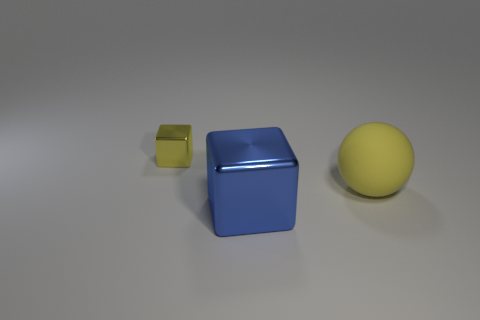Add 3 large things. How many objects exist? 6 Subtract all brown blocks. Subtract all yellow balls. How many blocks are left? 2 Subtract all yellow blocks. How many blocks are left? 1 Subtract all cubes. How many objects are left? 1 Subtract 1 cubes. How many cubes are left? 1 Subtract all purple balls. How many yellow cubes are left? 1 Subtract all big things. Subtract all big brown shiny cylinders. How many objects are left? 1 Add 3 matte balls. How many matte balls are left? 4 Add 3 large yellow matte objects. How many large yellow matte objects exist? 4 Subtract 0 blue cylinders. How many objects are left? 3 